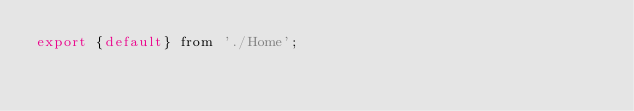Convert code to text. <code><loc_0><loc_0><loc_500><loc_500><_JavaScript_>export {default} from './Home';</code> 